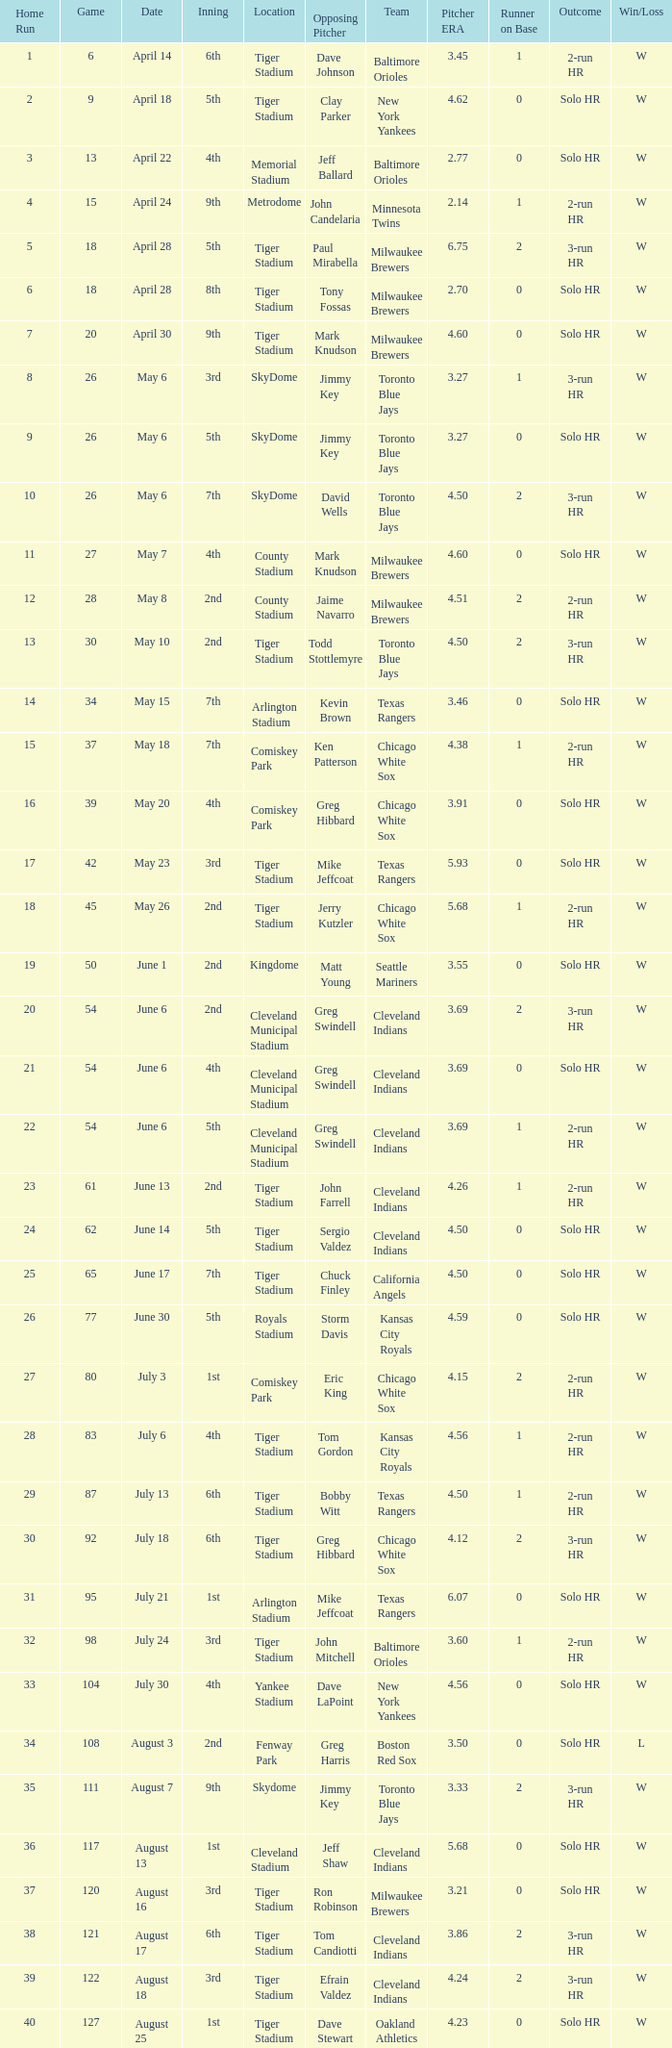What date was the game at Comiskey Park and had a 4th Inning? May 20. 